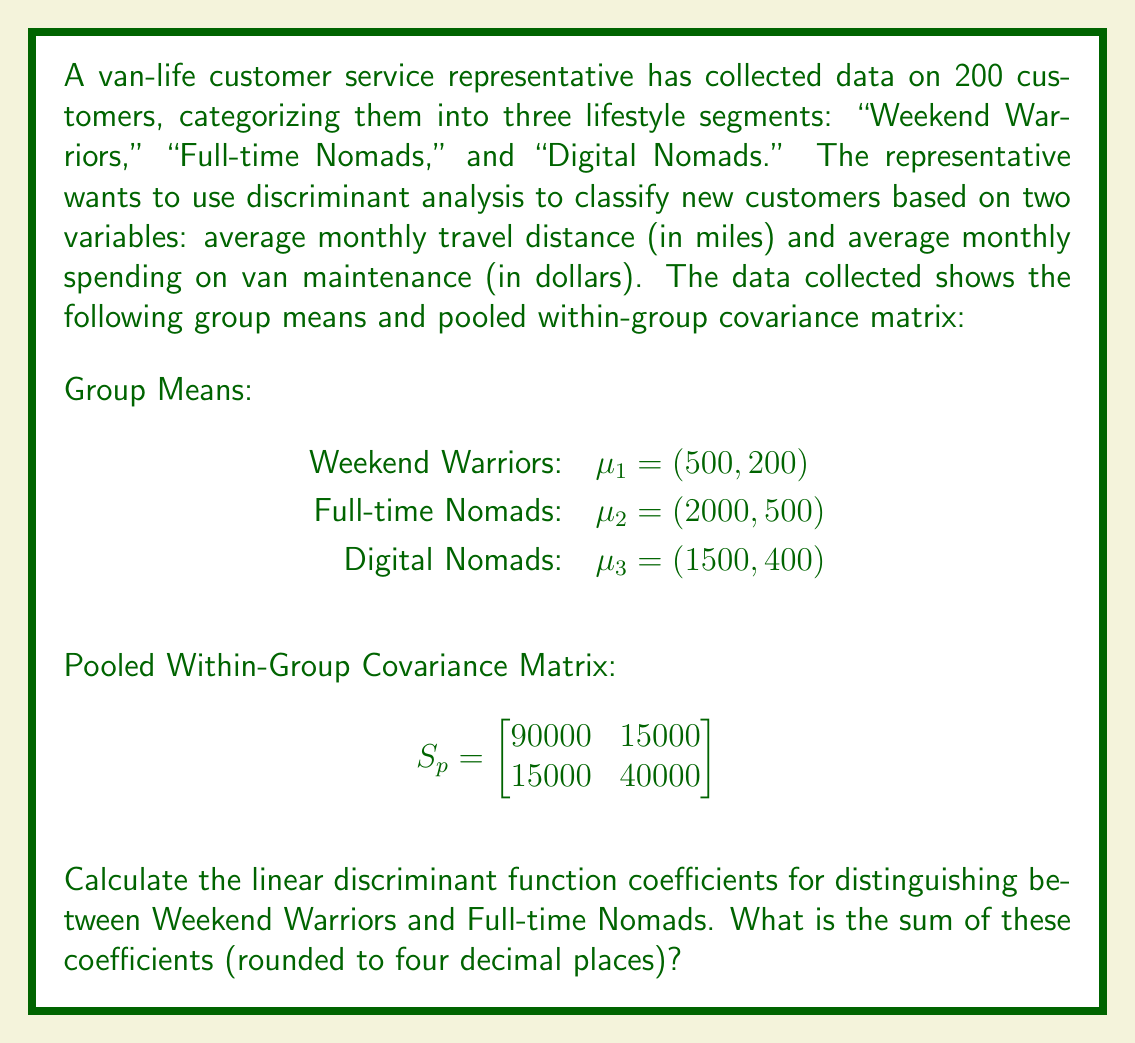Show me your answer to this math problem. To solve this problem, we'll follow these steps:

1) The linear discriminant function between two groups is given by:

   $a = S_p^{-1}(\mu_2 - \mu_1)$

   where $a$ is the vector of coefficients, $S_p^{-1}$ is the inverse of the pooled within-group covariance matrix, and $\mu_2$ and $\mu_1$ are the mean vectors of the two groups.

2) First, we need to calculate $S_p^{-1}$. The inverse of a 2x2 matrix $\begin{bmatrix} a & b \\ c & d \end{bmatrix}$ is:

   $\frac{1}{ad-bc} \begin{bmatrix} d & -b \\ -c & a \end{bmatrix}$

   So, $S_p^{-1} = \frac{1}{(90000 * 40000) - (15000 * 15000)} \begin{bmatrix} 40000 & -15000 \\ -15000 & 90000 \end{bmatrix}$

3) Simplifying:
   
   $S_p^{-1} = \frac{1}{3375000000} \begin{bmatrix} 40000 & -15000 \\ -15000 & 90000 \end{bmatrix}$

4) Now, we calculate $\mu_2 - \mu_1$:
   
   $\mu_2 - \mu_1 = (2000, 500) - (500, 200) = (1500, 300)$

5) Next, we multiply $S_p^{-1}$ by $(\mu_2 - \mu_1)$:

   $a = \frac{1}{3375000000} \begin{bmatrix} 40000 & -15000 \\ -15000 & 90000 \end{bmatrix} \begin{bmatrix} 1500 \\ 300 \end{bmatrix}$

6) Performing the matrix multiplication:

   $a = \frac{1}{3375000000} \begin{bmatrix} (40000 * 1500) + (-15000 * 300) \\ (-15000 * 1500) + (90000 * 300) \end{bmatrix}$

7) Simplifying:

   $a = \frac{1}{3375000000} \begin{bmatrix} 55500000 \\ 4500000 \end{bmatrix}$

8) Dividing:

   $a = \begin{bmatrix} 0.0164444... \\ 0.0013333... \end{bmatrix}$

9) The sum of these coefficients is:

   $0.0164444... + 0.0013333... = 0.0177777...$

10) Rounding to four decimal places:

    $0.0178$
Answer: The sum of the linear discriminant function coefficients, rounded to four decimal places, is 0.0178. 